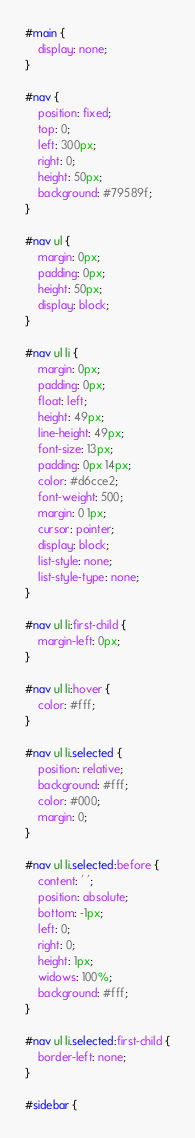Convert code to text. <code><loc_0><loc_0><loc_500><loc_500><_CSS_>#main {
    display: none;
}

#nav {
    position: fixed;
    top: 0;
    left: 300px;
    right: 0;
    height: 50px;
    background: #79589f;
}

#nav ul {
    margin: 0px;
    padding: 0px;
    height: 50px;
    display: block;
}

#nav ul li {
    margin: 0px;
    padding: 0px;
    float: left;
    height: 49px;
    line-height: 49px;
    font-size: 13px;
    padding: 0px 14px;
    color: #d6cce2;
    font-weight: 500;
    margin: 0 1px;
    cursor: pointer;
    display: block;
    list-style: none;
    list-style-type: none;
}

#nav ul li:first-child {
    margin-left: 0px;
}

#nav ul li:hover {
    color: #fff;
}

#nav ul li.selected {
    position: relative;
    background: #fff;
    color: #000;
    margin: 0;
}

#nav ul li.selected:before {
    content: ' ';
    position: absolute;
    bottom: -1px;
    left: 0;
    right: 0;
    height: 1px;
    widows: 100%;
    background: #fff;
}

#nav ul li.selected:first-child {
    border-left: none;
}

#sidebar {</code> 